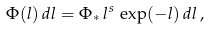<formula> <loc_0><loc_0><loc_500><loc_500>\Phi ( l ) \, d l = \Phi _ { * } \, l ^ { s } \, \exp ( - l ) \, d l \, ,</formula> 